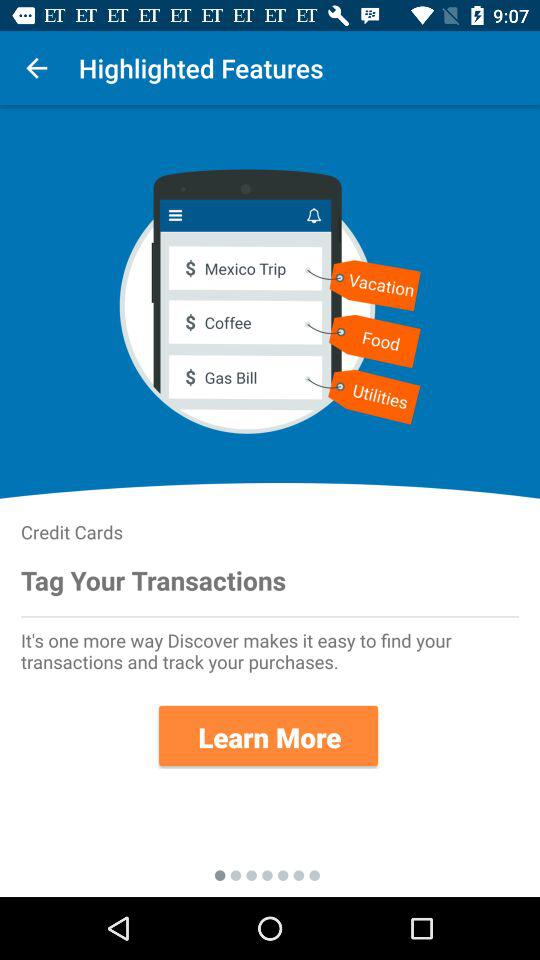Which category does the gas bill fall under? The gas bill falls under the "Utilities" category. 